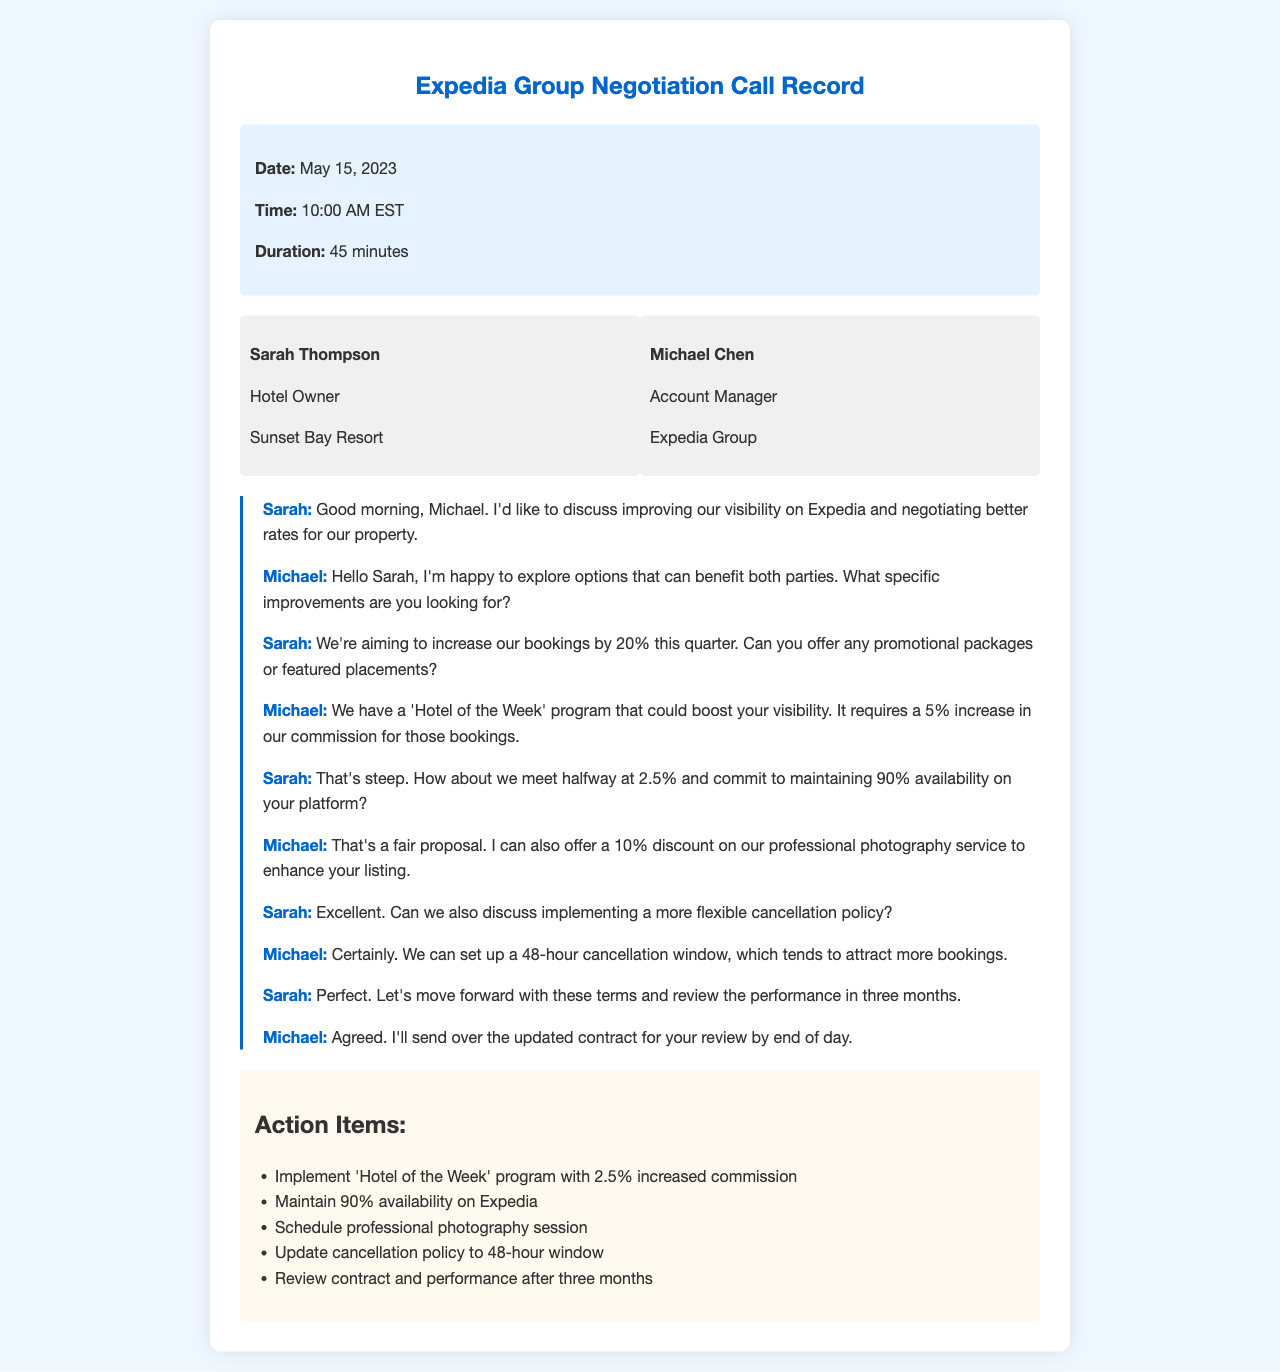what is the date of the call? The date of the call is explicitly stated in the document.
Answer: May 15, 2023 who is the hotel owner mentioned in the call? The hotel owner is identified in the participant section of the document.
Answer: Sarah Thompson what program did Michael suggest to improve visibility? The program he suggested is directly mentioned in the conversation.
Answer: Hotel of the Week what commission increase did Michael propose for the visibility program? The proposed commission increase can be found in Michael's response regarding the program.
Answer: 5% what was Sarah's counter-offer for the commission increase? The counter-offer is stated clearly in Sarah's response during the negotiation.
Answer: 2.5% what cancellation policy was discussed in the call? The cancellation policy is outlined in the dialogue between Sarah and Michael.
Answer: 48-hour cancellation window how long was the duration of the call? The duration is explicitly listed in the call information.
Answer: 45 minutes when will the contract be sent for review? The timing for sending the contract is mentioned at the end of the call.
Answer: by end of day what is the first action item listed after the call? The action items are clearly outlined in a dedicated section after the transcript.
Answer: Implement 'Hotel of the Week' program with 2.5% increased commission 